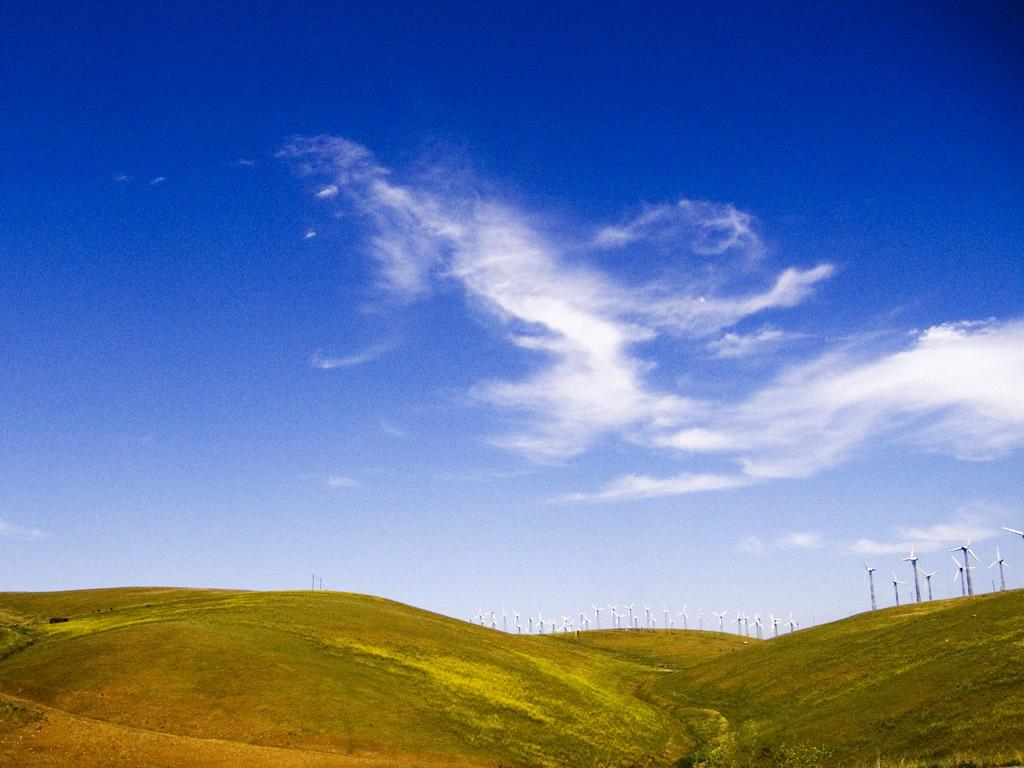What can be seen in the sky in the image? There are clouds in the sky in the image. What structures are present in the image? There are windmills in the image. What type of vegetation is visible in the image? There is green grass in the image. What type of care is being provided to the windmills in the image? There is no indication in the image that any care is being provided to the windmills. What type of loss is depicted in the image? There is no loss depicted in the image; it features clouds, windmills, and green grass. 